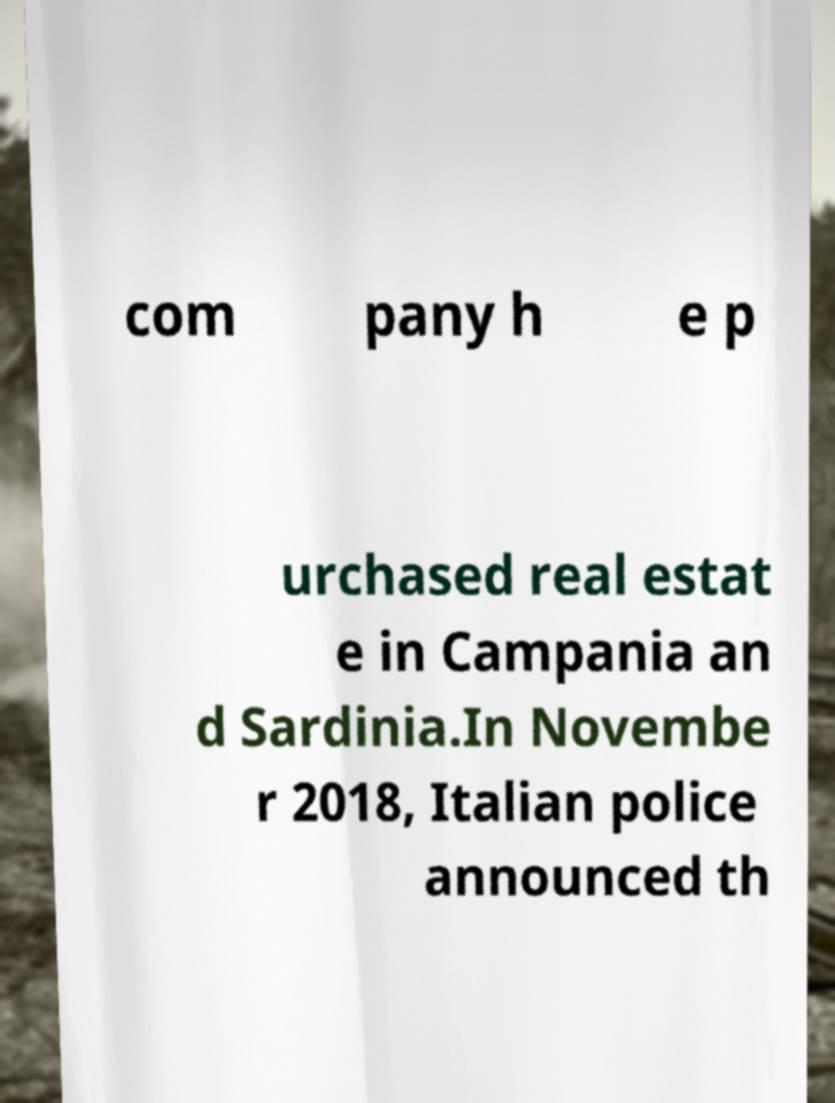What messages or text are displayed in this image? I need them in a readable, typed format. com pany h e p urchased real estat e in Campania an d Sardinia.In Novembe r 2018, Italian police announced th 